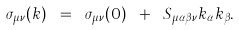<formula> <loc_0><loc_0><loc_500><loc_500>\sigma _ { \mu \nu } ( { k } ) \ = \ \sigma _ { \mu \nu } ( 0 ) \ + \ S _ { \mu \alpha \beta \nu } k _ { \alpha } k _ { \beta } .</formula> 